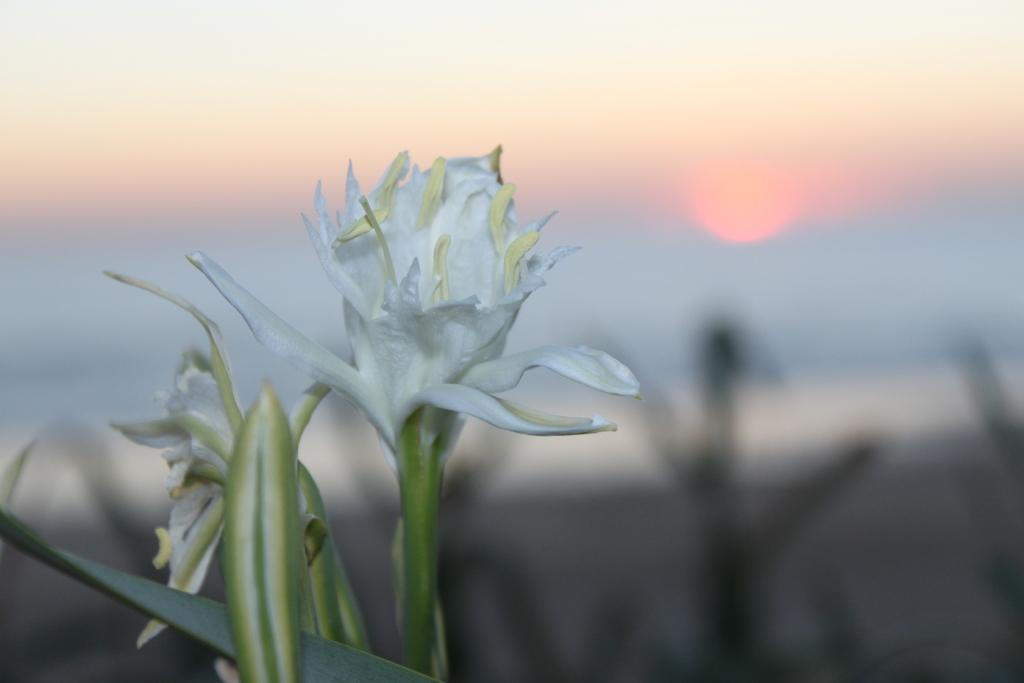What is the main subject of the image? There is a flower in the center of the image. What can be seen in the background of the image? There is sun visible in the background of the image. What type of ghost can be seen interacting with the flower in the image? There is no ghost present in the image; it features a flower and sun in the background. How does the friction between the flower and the ground affect the flower's movement in the image? The flower is stationary in the image, so there is no movement to be affected by friction. 